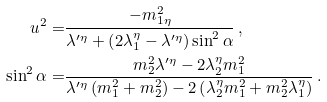Convert formula to latex. <formula><loc_0><loc_0><loc_500><loc_500>u ^ { 2 } = & \frac { - m _ { 1 \eta } ^ { 2 } } { \lambda ^ { \prime \eta } + \left ( 2 \lambda _ { 1 } ^ { \eta } - \lambda ^ { \prime \eta } \right ) \sin ^ { 2 } \alpha } \, , \\ \sin ^ { 2 } \alpha = & \frac { m _ { 2 } ^ { 2 } \lambda ^ { \prime \eta } - 2 \lambda _ { 2 } ^ { \eta } m _ { 1 } ^ { 2 } } { \lambda ^ { \prime \eta } \left ( m _ { 1 } ^ { 2 } + m _ { 2 } ^ { 2 } \right ) - 2 \left ( \lambda _ { 2 } ^ { \eta } m _ { 1 } ^ { 2 } + m _ { 2 } ^ { 2 } \lambda _ { 1 } ^ { \eta } \right ) } \, .</formula> 